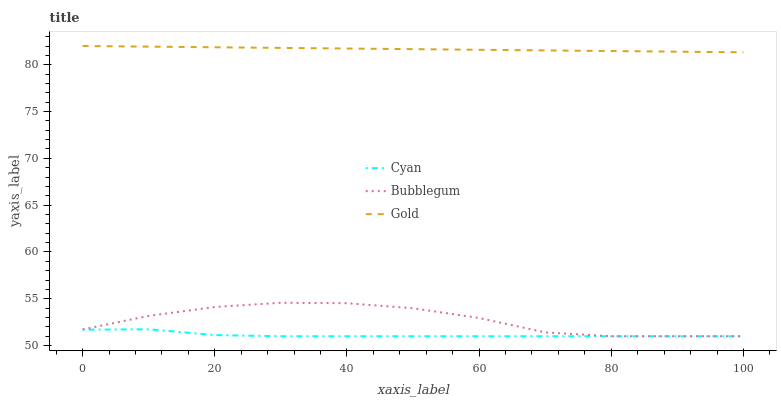Does Cyan have the minimum area under the curve?
Answer yes or no. Yes. Does Gold have the maximum area under the curve?
Answer yes or no. Yes. Does Bubblegum have the minimum area under the curve?
Answer yes or no. No. Does Bubblegum have the maximum area under the curve?
Answer yes or no. No. Is Gold the smoothest?
Answer yes or no. Yes. Is Bubblegum the roughest?
Answer yes or no. Yes. Is Bubblegum the smoothest?
Answer yes or no. No. Is Gold the roughest?
Answer yes or no. No. Does Cyan have the lowest value?
Answer yes or no. Yes. Does Gold have the lowest value?
Answer yes or no. No. Does Gold have the highest value?
Answer yes or no. Yes. Does Bubblegum have the highest value?
Answer yes or no. No. Is Cyan less than Gold?
Answer yes or no. Yes. Is Gold greater than Cyan?
Answer yes or no. Yes. Does Cyan intersect Bubblegum?
Answer yes or no. Yes. Is Cyan less than Bubblegum?
Answer yes or no. No. Is Cyan greater than Bubblegum?
Answer yes or no. No. Does Cyan intersect Gold?
Answer yes or no. No. 